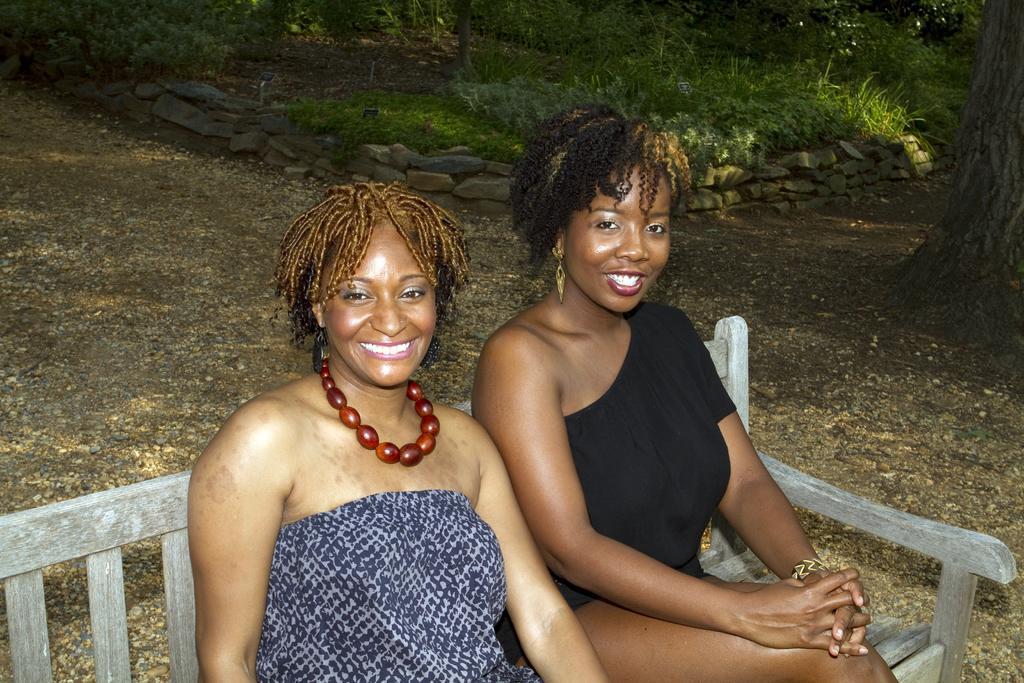In one or two sentences, can you explain what this image depicts? In this picture we can see two ladies one among them in blue color and other and black color sitting on the sofa and behind them there are some plants, trees, stones and some trees. 